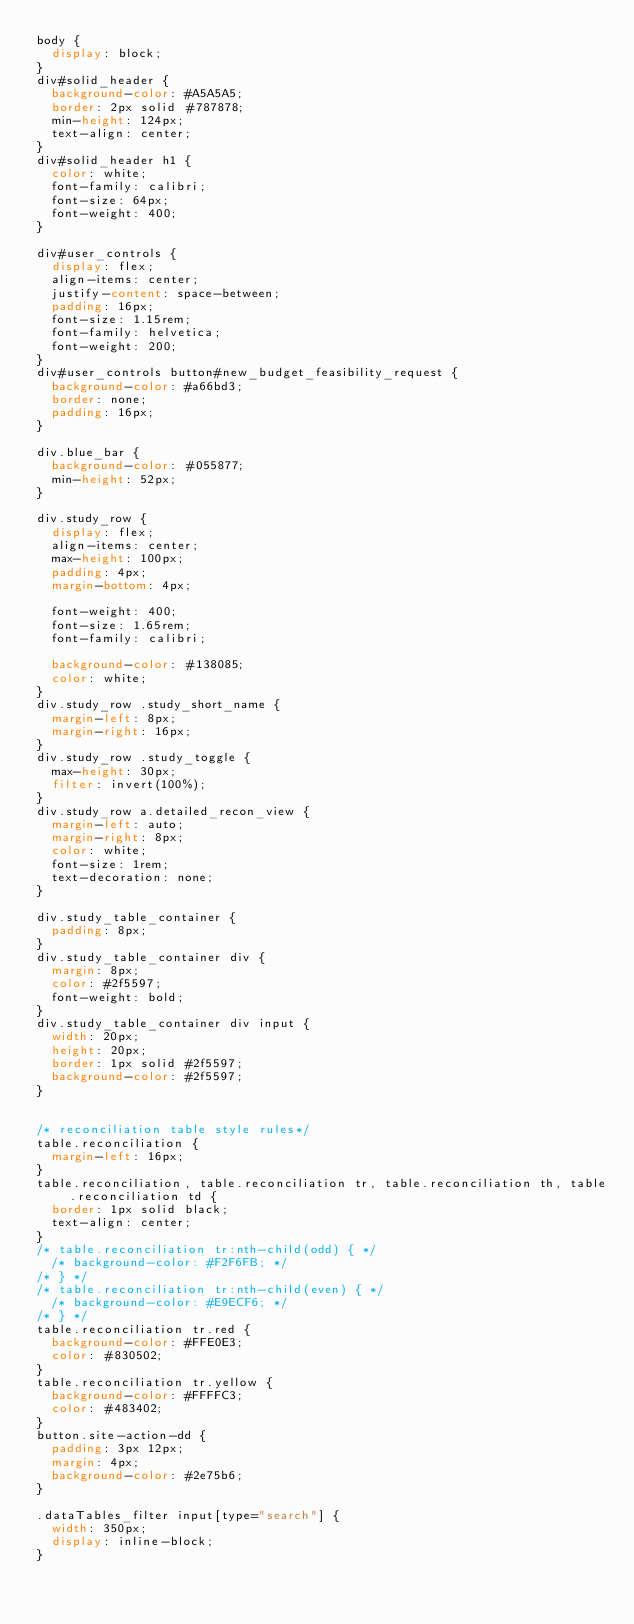Convert code to text. <code><loc_0><loc_0><loc_500><loc_500><_CSS_>body {
	display: block;
}
div#solid_header {
	background-color: #A5A5A5;
	border: 2px solid #787878;
	min-height: 124px;
	text-align: center;
}
div#solid_header h1 {
	color: white;
	font-family: calibri;
	font-size: 64px;
	font-weight: 400;
}

div#user_controls {
	display: flex;
	align-items: center;
	justify-content: space-between;
	padding: 16px;
	font-size: 1.15rem;
	font-family: helvetica;
	font-weight: 200;
}
div#user_controls button#new_budget_feasibility_request {
	background-color: #a66bd3;
	border: none;
	padding: 16px;
}

div.blue_bar {
	background-color: #055877;
	min-height: 52px;
}

div.study_row {
	display: flex;
	align-items: center;
	max-height: 100px;
	padding: 4px;
	margin-bottom: 4px;
	
	font-weight: 400;
	font-size: 1.65rem;
	font-family: calibri;
	
	background-color: #138085;
	color: white;
}
div.study_row .study_short_name {
	margin-left: 8px;
	margin-right: 16px;
}
div.study_row .study_toggle {
	max-height: 30px;
	filter: invert(100%);
}
div.study_row a.detailed_recon_view {
	margin-left: auto;
	margin-right: 8px;
	color: white;
	font-size: 1rem;
	text-decoration: none;
}

div.study_table_container {
	padding: 8px;
}
div.study_table_container div {
	margin: 8px;
	color: #2f5597;
	font-weight: bold;
}
div.study_table_container div input {
	width: 20px;
	height: 20px;
	border: 1px solid #2f5597;
	background-color: #2f5597;
}


/* reconciliation table style rules*/
table.reconciliation {
	margin-left: 16px;
}
table.reconciliation, table.reconciliation tr, table.reconciliation th, table.reconciliation td {
	border: 1px solid black;
	text-align: center;
}
/* table.reconciliation tr:nth-child(odd) { */
	/* background-color: #F2F6FB; */
/* } */
/* table.reconciliation tr:nth-child(even) { */
	/* background-color: #E9ECF6; */
/* } */
table.reconciliation tr.red {
	background-color: #FFE0E3;
	color: #830502;
}
table.reconciliation tr.yellow {
	background-color: #FFFFC3;
	color: #483402;
}
button.site-action-dd {
	padding: 3px 12px;
	margin: 4px;
	background-color: #2e75b6;
}

.dataTables_filter input[type="search"] {
	width: 350px;
	display: inline-block;
}</code> 